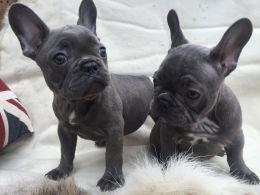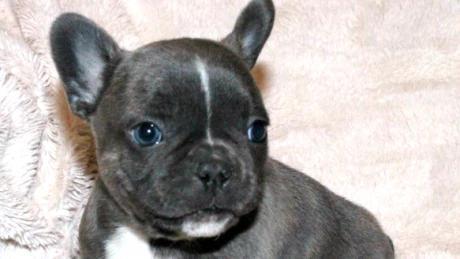The first image is the image on the left, the second image is the image on the right. Examine the images to the left and right. Is the description "The lefthand image contains exactly one dog, which is standing on all fours, and the right image shows one sitting dog." accurate? Answer yes or no. No. The first image is the image on the left, the second image is the image on the right. Considering the images on both sides, is "The dog in the right image is wearing a human-like accessory." valid? Answer yes or no. No. 